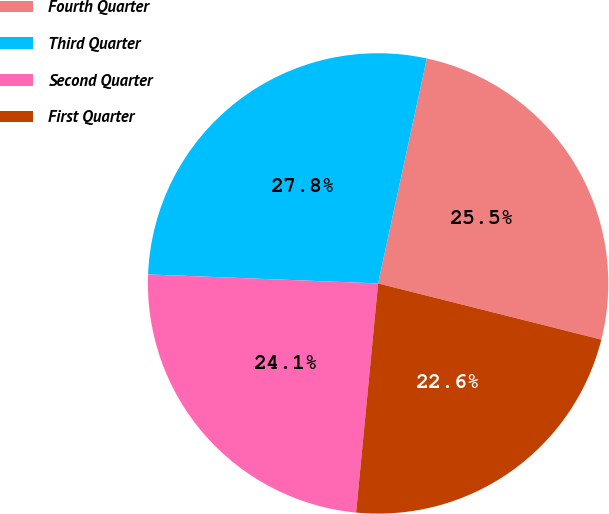<chart> <loc_0><loc_0><loc_500><loc_500><pie_chart><fcel>Fourth Quarter<fcel>Third Quarter<fcel>Second Quarter<fcel>First Quarter<nl><fcel>25.53%<fcel>27.77%<fcel>24.1%<fcel>22.6%<nl></chart> 